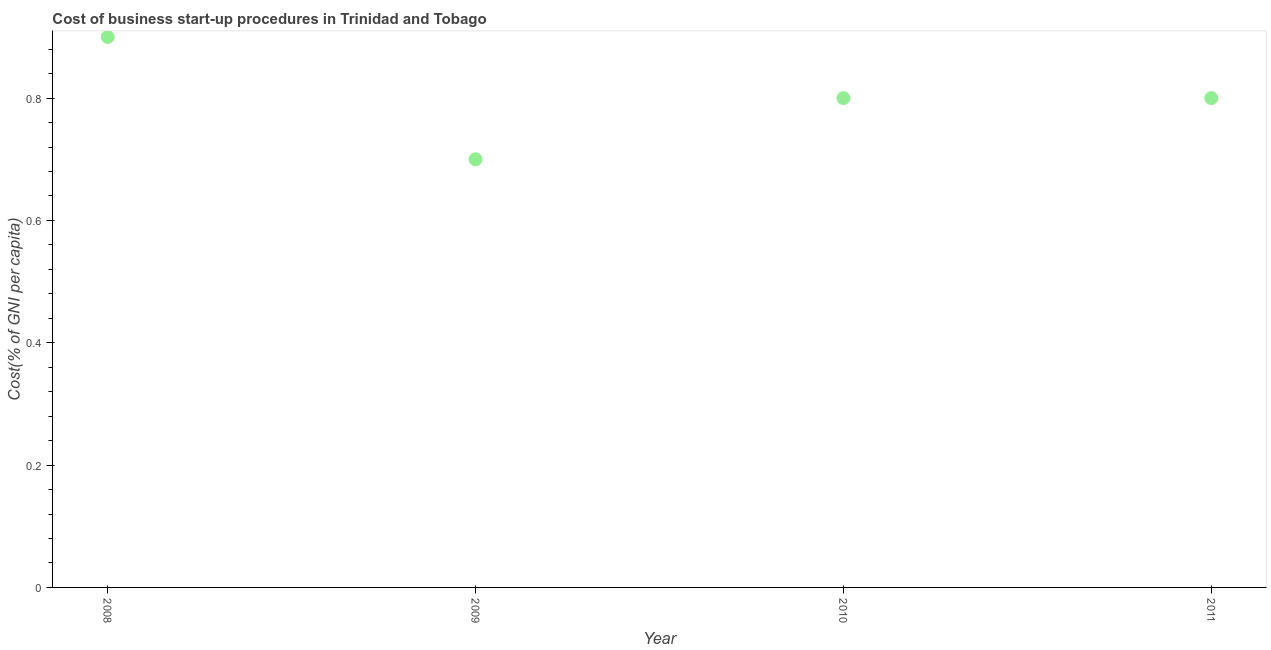What is the cost of business startup procedures in 2008?
Your answer should be very brief. 0.9. Across all years, what is the maximum cost of business startup procedures?
Provide a succinct answer. 0.9. Across all years, what is the minimum cost of business startup procedures?
Your answer should be compact. 0.7. In which year was the cost of business startup procedures maximum?
Offer a very short reply. 2008. In which year was the cost of business startup procedures minimum?
Make the answer very short. 2009. What is the difference between the cost of business startup procedures in 2010 and 2011?
Make the answer very short. 0. What is the median cost of business startup procedures?
Keep it short and to the point. 0.8. In how many years, is the cost of business startup procedures greater than 0.2 %?
Your response must be concise. 4. Do a majority of the years between 2010 and 2008 (inclusive) have cost of business startup procedures greater than 0.68 %?
Your answer should be compact. No. What is the ratio of the cost of business startup procedures in 2010 to that in 2011?
Your response must be concise. 1. What is the difference between the highest and the second highest cost of business startup procedures?
Your response must be concise. 0.1. What is the difference between the highest and the lowest cost of business startup procedures?
Give a very brief answer. 0.2. In how many years, is the cost of business startup procedures greater than the average cost of business startup procedures taken over all years?
Your answer should be very brief. 1. How many dotlines are there?
Make the answer very short. 1. What is the difference between two consecutive major ticks on the Y-axis?
Offer a terse response. 0.2. What is the title of the graph?
Provide a succinct answer. Cost of business start-up procedures in Trinidad and Tobago. What is the label or title of the Y-axis?
Offer a very short reply. Cost(% of GNI per capita). What is the Cost(% of GNI per capita) in 2009?
Keep it short and to the point. 0.7. What is the Cost(% of GNI per capita) in 2011?
Provide a short and direct response. 0.8. What is the difference between the Cost(% of GNI per capita) in 2008 and 2009?
Your answer should be very brief. 0.2. What is the difference between the Cost(% of GNI per capita) in 2009 and 2010?
Offer a terse response. -0.1. What is the difference between the Cost(% of GNI per capita) in 2009 and 2011?
Offer a very short reply. -0.1. What is the difference between the Cost(% of GNI per capita) in 2010 and 2011?
Your response must be concise. 0. What is the ratio of the Cost(% of GNI per capita) in 2008 to that in 2009?
Provide a succinct answer. 1.29. What is the ratio of the Cost(% of GNI per capita) in 2008 to that in 2010?
Your answer should be very brief. 1.12. What is the ratio of the Cost(% of GNI per capita) in 2009 to that in 2011?
Offer a very short reply. 0.88. What is the ratio of the Cost(% of GNI per capita) in 2010 to that in 2011?
Give a very brief answer. 1. 